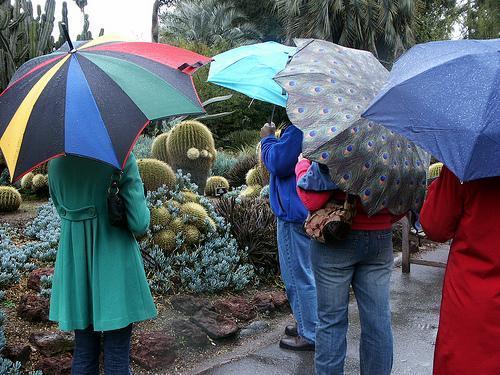How many umbrellas are in the picture?
Give a very brief answer. 4. 